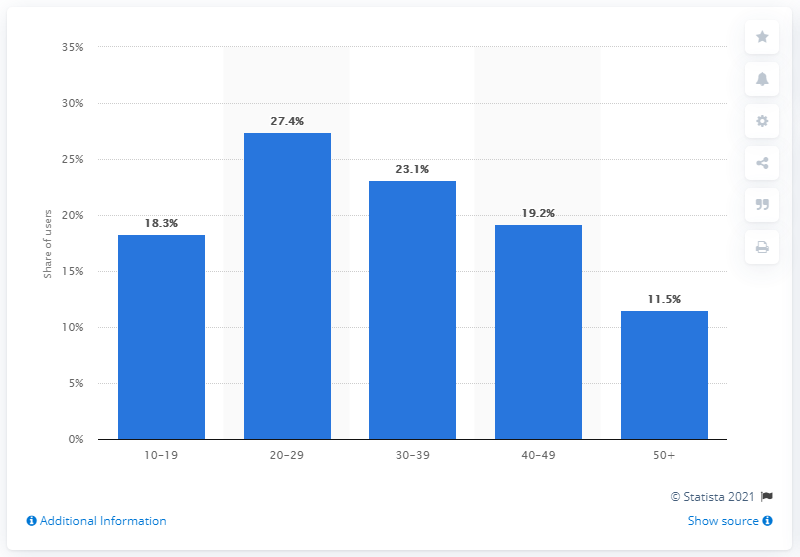List a handful of essential elements in this visual. In Instagram's user base, 23.1% of users were between the ages of 30 and 39. According to data from January 2021, approximately 27.4% of Instagram's monthly active users were in their 20s. 